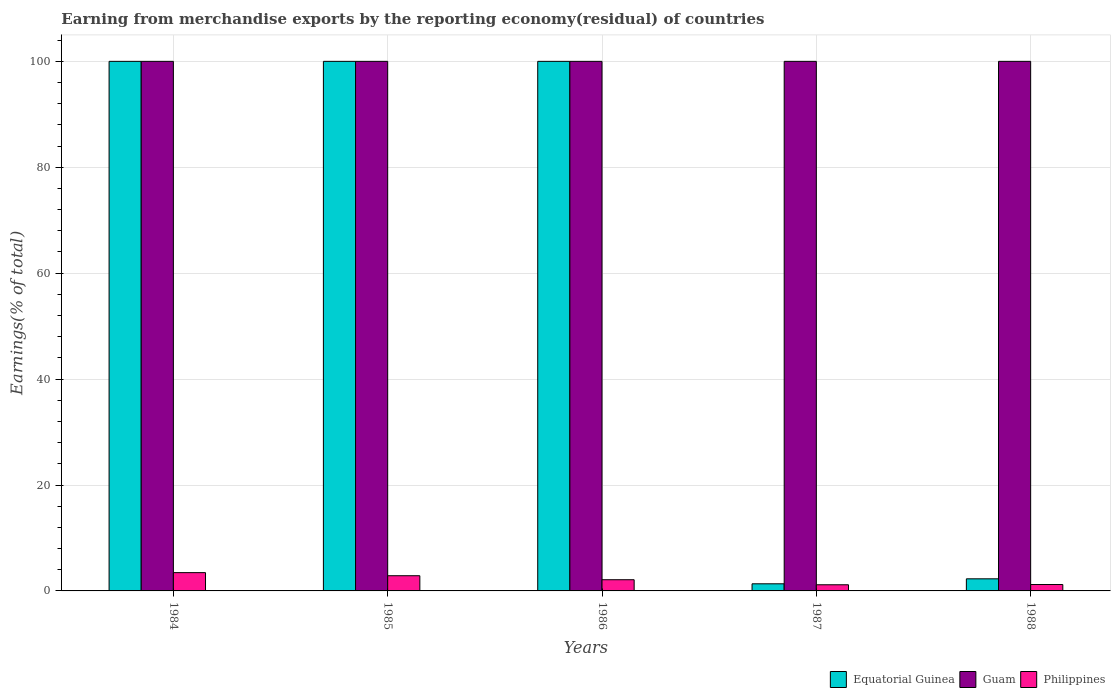How many groups of bars are there?
Provide a succinct answer. 5. Are the number of bars per tick equal to the number of legend labels?
Your response must be concise. Yes. Are the number of bars on each tick of the X-axis equal?
Make the answer very short. Yes. How many bars are there on the 2nd tick from the left?
Your answer should be compact. 3. How many bars are there on the 5th tick from the right?
Ensure brevity in your answer.  3. What is the label of the 5th group of bars from the left?
Your answer should be very brief. 1988. What is the percentage of amount earned from merchandise exports in Guam in 1986?
Ensure brevity in your answer.  100. Across all years, what is the maximum percentage of amount earned from merchandise exports in Equatorial Guinea?
Your answer should be very brief. 100. Across all years, what is the minimum percentage of amount earned from merchandise exports in Philippines?
Provide a short and direct response. 1.16. In which year was the percentage of amount earned from merchandise exports in Equatorial Guinea maximum?
Give a very brief answer. 1984. In which year was the percentage of amount earned from merchandise exports in Philippines minimum?
Provide a short and direct response. 1987. What is the difference between the percentage of amount earned from merchandise exports in Philippines in 1984 and that in 1986?
Give a very brief answer. 1.34. What is the difference between the percentage of amount earned from merchandise exports in Guam in 1987 and the percentage of amount earned from merchandise exports in Philippines in 1985?
Your response must be concise. 97.13. What is the average percentage of amount earned from merchandise exports in Philippines per year?
Offer a terse response. 2.16. In the year 1988, what is the difference between the percentage of amount earned from merchandise exports in Philippines and percentage of amount earned from merchandise exports in Equatorial Guinea?
Give a very brief answer. -1.08. What is the ratio of the percentage of amount earned from merchandise exports in Equatorial Guinea in 1984 to that in 1988?
Your answer should be very brief. 43.74. Is the percentage of amount earned from merchandise exports in Guam in 1986 less than that in 1987?
Provide a short and direct response. No. Is the difference between the percentage of amount earned from merchandise exports in Philippines in 1985 and 1986 greater than the difference between the percentage of amount earned from merchandise exports in Equatorial Guinea in 1985 and 1986?
Your answer should be compact. Yes. What is the difference between the highest and the second highest percentage of amount earned from merchandise exports in Guam?
Your answer should be very brief. 0. What is the difference between the highest and the lowest percentage of amount earned from merchandise exports in Equatorial Guinea?
Give a very brief answer. 98.66. Is the sum of the percentage of amount earned from merchandise exports in Guam in 1986 and 1987 greater than the maximum percentage of amount earned from merchandise exports in Equatorial Guinea across all years?
Make the answer very short. Yes. What does the 2nd bar from the right in 1984 represents?
Keep it short and to the point. Guam. Is it the case that in every year, the sum of the percentage of amount earned from merchandise exports in Philippines and percentage of amount earned from merchandise exports in Guam is greater than the percentage of amount earned from merchandise exports in Equatorial Guinea?
Give a very brief answer. Yes. Are all the bars in the graph horizontal?
Ensure brevity in your answer.  No. How many years are there in the graph?
Your response must be concise. 5. What is the difference between two consecutive major ticks on the Y-axis?
Ensure brevity in your answer.  20. Are the values on the major ticks of Y-axis written in scientific E-notation?
Provide a succinct answer. No. Does the graph contain grids?
Provide a succinct answer. Yes. Where does the legend appear in the graph?
Give a very brief answer. Bottom right. How are the legend labels stacked?
Offer a terse response. Horizontal. What is the title of the graph?
Ensure brevity in your answer.  Earning from merchandise exports by the reporting economy(residual) of countries. What is the label or title of the Y-axis?
Your answer should be very brief. Earnings(% of total). What is the Earnings(% of total) in Equatorial Guinea in 1984?
Make the answer very short. 100. What is the Earnings(% of total) in Guam in 1984?
Ensure brevity in your answer.  100. What is the Earnings(% of total) of Philippines in 1984?
Ensure brevity in your answer.  3.45. What is the Earnings(% of total) of Guam in 1985?
Make the answer very short. 100. What is the Earnings(% of total) in Philippines in 1985?
Make the answer very short. 2.87. What is the Earnings(% of total) in Guam in 1986?
Provide a short and direct response. 100. What is the Earnings(% of total) in Philippines in 1986?
Offer a terse response. 2.11. What is the Earnings(% of total) of Equatorial Guinea in 1987?
Your response must be concise. 1.34. What is the Earnings(% of total) of Philippines in 1987?
Make the answer very short. 1.16. What is the Earnings(% of total) of Equatorial Guinea in 1988?
Ensure brevity in your answer.  2.29. What is the Earnings(% of total) in Philippines in 1988?
Provide a short and direct response. 1.21. Across all years, what is the maximum Earnings(% of total) of Equatorial Guinea?
Provide a short and direct response. 100. Across all years, what is the maximum Earnings(% of total) in Guam?
Your answer should be compact. 100. Across all years, what is the maximum Earnings(% of total) of Philippines?
Keep it short and to the point. 3.45. Across all years, what is the minimum Earnings(% of total) in Equatorial Guinea?
Keep it short and to the point. 1.34. Across all years, what is the minimum Earnings(% of total) of Philippines?
Provide a succinct answer. 1.16. What is the total Earnings(% of total) of Equatorial Guinea in the graph?
Keep it short and to the point. 303.63. What is the total Earnings(% of total) of Guam in the graph?
Offer a very short reply. 500. What is the total Earnings(% of total) of Philippines in the graph?
Provide a short and direct response. 10.8. What is the difference between the Earnings(% of total) of Equatorial Guinea in 1984 and that in 1985?
Offer a terse response. 0. What is the difference between the Earnings(% of total) of Guam in 1984 and that in 1985?
Your answer should be compact. 0. What is the difference between the Earnings(% of total) in Philippines in 1984 and that in 1985?
Your answer should be very brief. 0.58. What is the difference between the Earnings(% of total) in Philippines in 1984 and that in 1986?
Your answer should be very brief. 1.34. What is the difference between the Earnings(% of total) of Equatorial Guinea in 1984 and that in 1987?
Keep it short and to the point. 98.66. What is the difference between the Earnings(% of total) of Philippines in 1984 and that in 1987?
Your response must be concise. 2.29. What is the difference between the Earnings(% of total) in Equatorial Guinea in 1984 and that in 1988?
Offer a very short reply. 97.71. What is the difference between the Earnings(% of total) of Philippines in 1984 and that in 1988?
Keep it short and to the point. 2.24. What is the difference between the Earnings(% of total) in Equatorial Guinea in 1985 and that in 1986?
Offer a terse response. 0. What is the difference between the Earnings(% of total) of Guam in 1985 and that in 1986?
Your answer should be very brief. 0. What is the difference between the Earnings(% of total) of Philippines in 1985 and that in 1986?
Your answer should be very brief. 0.75. What is the difference between the Earnings(% of total) of Equatorial Guinea in 1985 and that in 1987?
Provide a short and direct response. 98.66. What is the difference between the Earnings(% of total) in Philippines in 1985 and that in 1987?
Ensure brevity in your answer.  1.71. What is the difference between the Earnings(% of total) in Equatorial Guinea in 1985 and that in 1988?
Provide a short and direct response. 97.71. What is the difference between the Earnings(% of total) in Guam in 1985 and that in 1988?
Your answer should be compact. 0. What is the difference between the Earnings(% of total) in Philippines in 1985 and that in 1988?
Keep it short and to the point. 1.66. What is the difference between the Earnings(% of total) of Equatorial Guinea in 1986 and that in 1987?
Provide a succinct answer. 98.66. What is the difference between the Earnings(% of total) of Guam in 1986 and that in 1987?
Ensure brevity in your answer.  0. What is the difference between the Earnings(% of total) of Philippines in 1986 and that in 1987?
Provide a short and direct response. 0.95. What is the difference between the Earnings(% of total) of Equatorial Guinea in 1986 and that in 1988?
Offer a terse response. 97.71. What is the difference between the Earnings(% of total) in Philippines in 1986 and that in 1988?
Offer a terse response. 0.9. What is the difference between the Earnings(% of total) in Equatorial Guinea in 1987 and that in 1988?
Provide a succinct answer. -0.94. What is the difference between the Earnings(% of total) in Philippines in 1987 and that in 1988?
Ensure brevity in your answer.  -0.05. What is the difference between the Earnings(% of total) of Equatorial Guinea in 1984 and the Earnings(% of total) of Philippines in 1985?
Keep it short and to the point. 97.13. What is the difference between the Earnings(% of total) in Guam in 1984 and the Earnings(% of total) in Philippines in 1985?
Your answer should be very brief. 97.13. What is the difference between the Earnings(% of total) of Equatorial Guinea in 1984 and the Earnings(% of total) of Guam in 1986?
Your answer should be compact. 0. What is the difference between the Earnings(% of total) of Equatorial Guinea in 1984 and the Earnings(% of total) of Philippines in 1986?
Offer a terse response. 97.89. What is the difference between the Earnings(% of total) of Guam in 1984 and the Earnings(% of total) of Philippines in 1986?
Ensure brevity in your answer.  97.89. What is the difference between the Earnings(% of total) in Equatorial Guinea in 1984 and the Earnings(% of total) in Guam in 1987?
Your response must be concise. 0. What is the difference between the Earnings(% of total) in Equatorial Guinea in 1984 and the Earnings(% of total) in Philippines in 1987?
Your answer should be very brief. 98.84. What is the difference between the Earnings(% of total) of Guam in 1984 and the Earnings(% of total) of Philippines in 1987?
Your answer should be very brief. 98.84. What is the difference between the Earnings(% of total) in Equatorial Guinea in 1984 and the Earnings(% of total) in Philippines in 1988?
Provide a short and direct response. 98.79. What is the difference between the Earnings(% of total) in Guam in 1984 and the Earnings(% of total) in Philippines in 1988?
Your answer should be compact. 98.79. What is the difference between the Earnings(% of total) in Equatorial Guinea in 1985 and the Earnings(% of total) in Philippines in 1986?
Provide a succinct answer. 97.89. What is the difference between the Earnings(% of total) of Guam in 1985 and the Earnings(% of total) of Philippines in 1986?
Your response must be concise. 97.89. What is the difference between the Earnings(% of total) of Equatorial Guinea in 1985 and the Earnings(% of total) of Philippines in 1987?
Your response must be concise. 98.84. What is the difference between the Earnings(% of total) of Guam in 1985 and the Earnings(% of total) of Philippines in 1987?
Offer a terse response. 98.84. What is the difference between the Earnings(% of total) in Equatorial Guinea in 1985 and the Earnings(% of total) in Philippines in 1988?
Your answer should be very brief. 98.79. What is the difference between the Earnings(% of total) in Guam in 1985 and the Earnings(% of total) in Philippines in 1988?
Offer a terse response. 98.79. What is the difference between the Earnings(% of total) of Equatorial Guinea in 1986 and the Earnings(% of total) of Guam in 1987?
Keep it short and to the point. 0. What is the difference between the Earnings(% of total) in Equatorial Guinea in 1986 and the Earnings(% of total) in Philippines in 1987?
Provide a short and direct response. 98.84. What is the difference between the Earnings(% of total) of Guam in 1986 and the Earnings(% of total) of Philippines in 1987?
Provide a short and direct response. 98.84. What is the difference between the Earnings(% of total) in Equatorial Guinea in 1986 and the Earnings(% of total) in Guam in 1988?
Your answer should be compact. 0. What is the difference between the Earnings(% of total) of Equatorial Guinea in 1986 and the Earnings(% of total) of Philippines in 1988?
Your response must be concise. 98.79. What is the difference between the Earnings(% of total) of Guam in 1986 and the Earnings(% of total) of Philippines in 1988?
Your response must be concise. 98.79. What is the difference between the Earnings(% of total) in Equatorial Guinea in 1987 and the Earnings(% of total) in Guam in 1988?
Give a very brief answer. -98.66. What is the difference between the Earnings(% of total) in Equatorial Guinea in 1987 and the Earnings(% of total) in Philippines in 1988?
Your answer should be compact. 0.14. What is the difference between the Earnings(% of total) in Guam in 1987 and the Earnings(% of total) in Philippines in 1988?
Offer a terse response. 98.79. What is the average Earnings(% of total) of Equatorial Guinea per year?
Provide a succinct answer. 60.73. What is the average Earnings(% of total) in Guam per year?
Provide a succinct answer. 100. What is the average Earnings(% of total) of Philippines per year?
Provide a short and direct response. 2.16. In the year 1984, what is the difference between the Earnings(% of total) in Equatorial Guinea and Earnings(% of total) in Philippines?
Your answer should be compact. 96.55. In the year 1984, what is the difference between the Earnings(% of total) of Guam and Earnings(% of total) of Philippines?
Make the answer very short. 96.55. In the year 1985, what is the difference between the Earnings(% of total) in Equatorial Guinea and Earnings(% of total) in Guam?
Keep it short and to the point. 0. In the year 1985, what is the difference between the Earnings(% of total) in Equatorial Guinea and Earnings(% of total) in Philippines?
Provide a short and direct response. 97.13. In the year 1985, what is the difference between the Earnings(% of total) in Guam and Earnings(% of total) in Philippines?
Make the answer very short. 97.13. In the year 1986, what is the difference between the Earnings(% of total) in Equatorial Guinea and Earnings(% of total) in Guam?
Provide a short and direct response. 0. In the year 1986, what is the difference between the Earnings(% of total) in Equatorial Guinea and Earnings(% of total) in Philippines?
Keep it short and to the point. 97.89. In the year 1986, what is the difference between the Earnings(% of total) of Guam and Earnings(% of total) of Philippines?
Provide a short and direct response. 97.89. In the year 1987, what is the difference between the Earnings(% of total) in Equatorial Guinea and Earnings(% of total) in Guam?
Your answer should be very brief. -98.66. In the year 1987, what is the difference between the Earnings(% of total) in Equatorial Guinea and Earnings(% of total) in Philippines?
Make the answer very short. 0.18. In the year 1987, what is the difference between the Earnings(% of total) of Guam and Earnings(% of total) of Philippines?
Offer a very short reply. 98.84. In the year 1988, what is the difference between the Earnings(% of total) of Equatorial Guinea and Earnings(% of total) of Guam?
Offer a very short reply. -97.71. In the year 1988, what is the difference between the Earnings(% of total) of Equatorial Guinea and Earnings(% of total) of Philippines?
Keep it short and to the point. 1.08. In the year 1988, what is the difference between the Earnings(% of total) in Guam and Earnings(% of total) in Philippines?
Give a very brief answer. 98.79. What is the ratio of the Earnings(% of total) in Equatorial Guinea in 1984 to that in 1985?
Your answer should be very brief. 1. What is the ratio of the Earnings(% of total) in Guam in 1984 to that in 1985?
Your answer should be compact. 1. What is the ratio of the Earnings(% of total) in Philippines in 1984 to that in 1985?
Make the answer very short. 1.2. What is the ratio of the Earnings(% of total) of Equatorial Guinea in 1984 to that in 1986?
Your answer should be compact. 1. What is the ratio of the Earnings(% of total) of Philippines in 1984 to that in 1986?
Keep it short and to the point. 1.63. What is the ratio of the Earnings(% of total) of Equatorial Guinea in 1984 to that in 1987?
Provide a succinct answer. 74.41. What is the ratio of the Earnings(% of total) of Philippines in 1984 to that in 1987?
Your response must be concise. 2.97. What is the ratio of the Earnings(% of total) of Equatorial Guinea in 1984 to that in 1988?
Make the answer very short. 43.74. What is the ratio of the Earnings(% of total) of Philippines in 1984 to that in 1988?
Provide a short and direct response. 2.86. What is the ratio of the Earnings(% of total) of Philippines in 1985 to that in 1986?
Provide a short and direct response. 1.36. What is the ratio of the Earnings(% of total) of Equatorial Guinea in 1985 to that in 1987?
Make the answer very short. 74.41. What is the ratio of the Earnings(% of total) in Philippines in 1985 to that in 1987?
Your answer should be very brief. 2.47. What is the ratio of the Earnings(% of total) in Equatorial Guinea in 1985 to that in 1988?
Make the answer very short. 43.74. What is the ratio of the Earnings(% of total) in Guam in 1985 to that in 1988?
Give a very brief answer. 1. What is the ratio of the Earnings(% of total) in Philippines in 1985 to that in 1988?
Your answer should be compact. 2.37. What is the ratio of the Earnings(% of total) of Equatorial Guinea in 1986 to that in 1987?
Ensure brevity in your answer.  74.41. What is the ratio of the Earnings(% of total) in Guam in 1986 to that in 1987?
Your answer should be very brief. 1. What is the ratio of the Earnings(% of total) in Philippines in 1986 to that in 1987?
Offer a very short reply. 1.82. What is the ratio of the Earnings(% of total) of Equatorial Guinea in 1986 to that in 1988?
Your answer should be compact. 43.74. What is the ratio of the Earnings(% of total) in Guam in 1986 to that in 1988?
Make the answer very short. 1. What is the ratio of the Earnings(% of total) in Philippines in 1986 to that in 1988?
Provide a succinct answer. 1.75. What is the ratio of the Earnings(% of total) in Equatorial Guinea in 1987 to that in 1988?
Your answer should be very brief. 0.59. What is the ratio of the Earnings(% of total) in Philippines in 1987 to that in 1988?
Make the answer very short. 0.96. What is the difference between the highest and the second highest Earnings(% of total) of Philippines?
Give a very brief answer. 0.58. What is the difference between the highest and the lowest Earnings(% of total) in Equatorial Guinea?
Give a very brief answer. 98.66. What is the difference between the highest and the lowest Earnings(% of total) in Philippines?
Your answer should be compact. 2.29. 